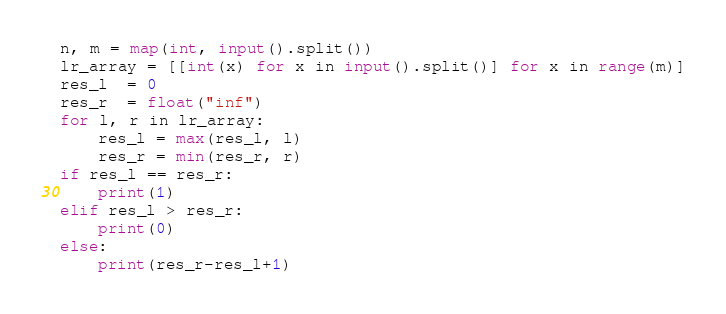Convert code to text. <code><loc_0><loc_0><loc_500><loc_500><_Python_>n, m = map(int, input().split())
lr_array = [[int(x) for x in input().split()] for x in range(m)]
res_l  = 0
res_r  = float("inf")
for l, r in lr_array:
    res_l = max(res_l, l)
    res_r = min(res_r, r)
if res_l == res_r:
    print(1)
elif res_l > res_r:
    print(0)
else:
    print(res_r-res_l+1)
</code> 